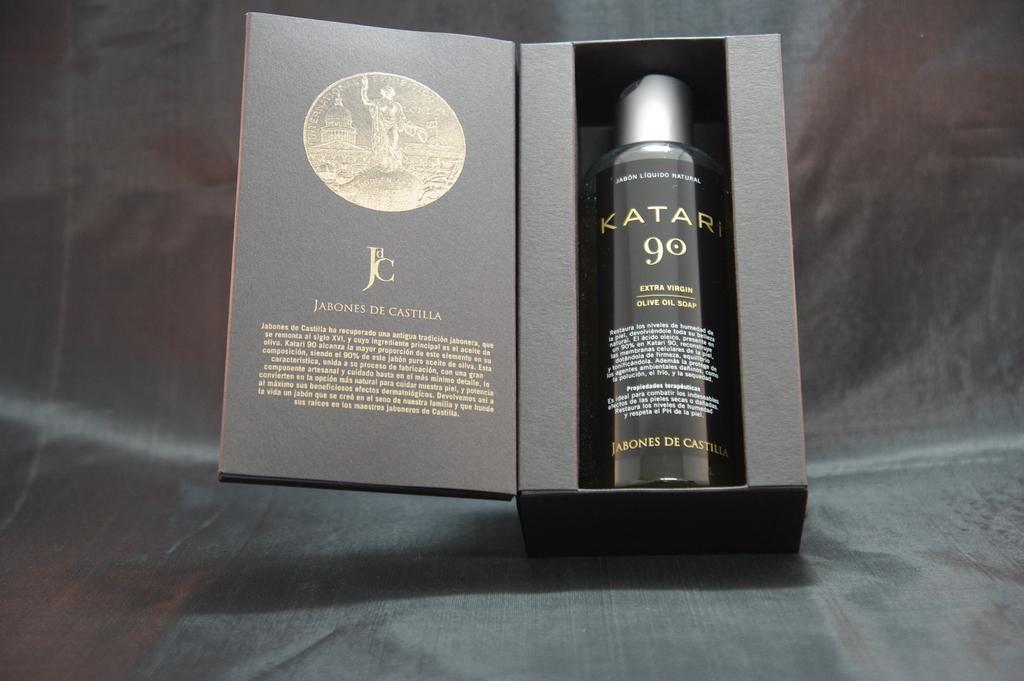What is the name of this cologne?
Give a very brief answer. Katari. Who makes this cologne?
Your response must be concise. Jabones de castilla. 